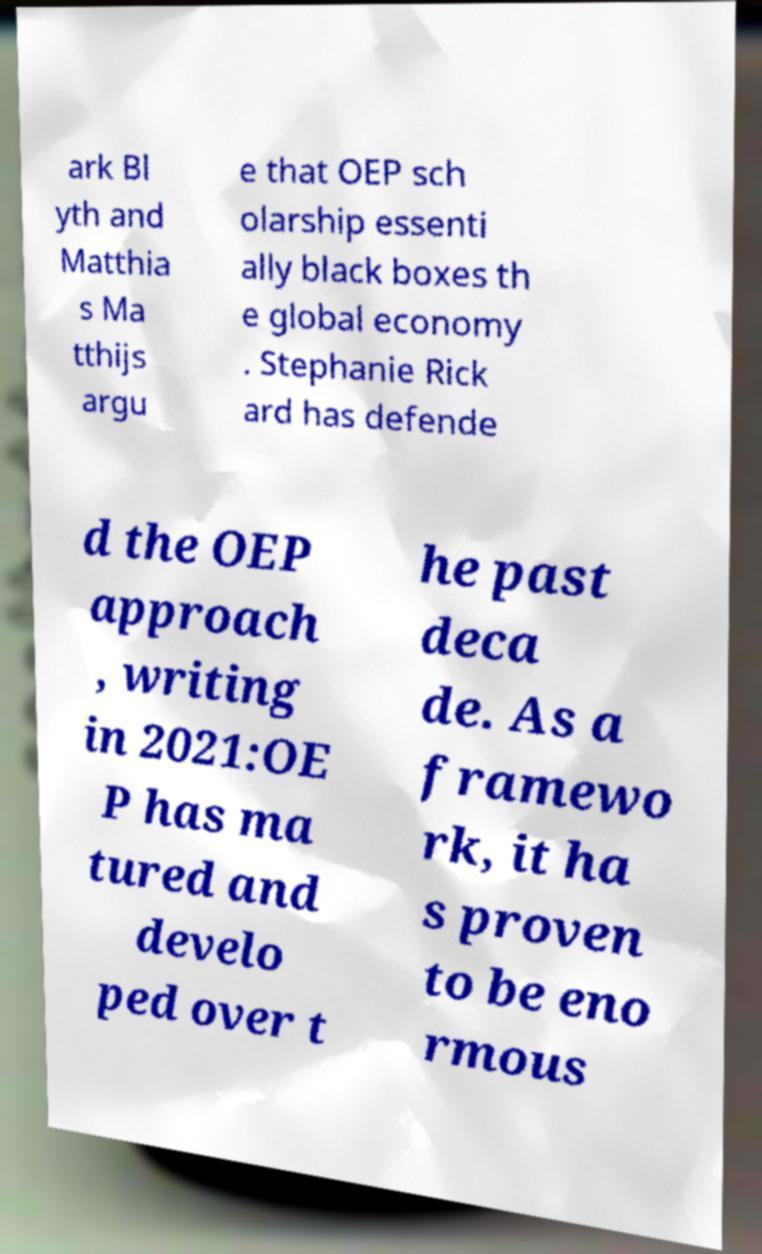Could you extract and type out the text from this image? ark Bl yth and Matthia s Ma tthijs argu e that OEP sch olarship essenti ally black boxes th e global economy . Stephanie Rick ard has defende d the OEP approach , writing in 2021:OE P has ma tured and develo ped over t he past deca de. As a framewo rk, it ha s proven to be eno rmous 